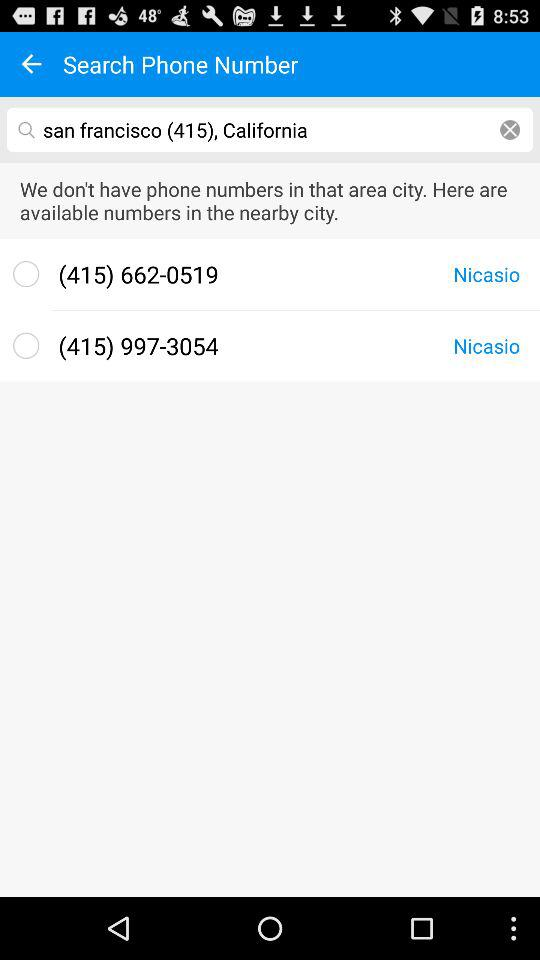What is the given code? The given code is 415. 